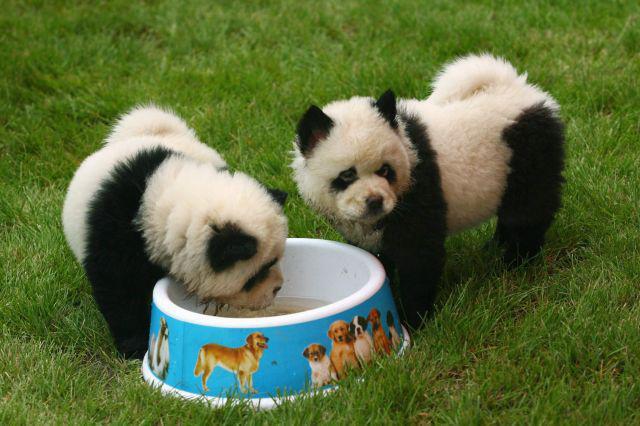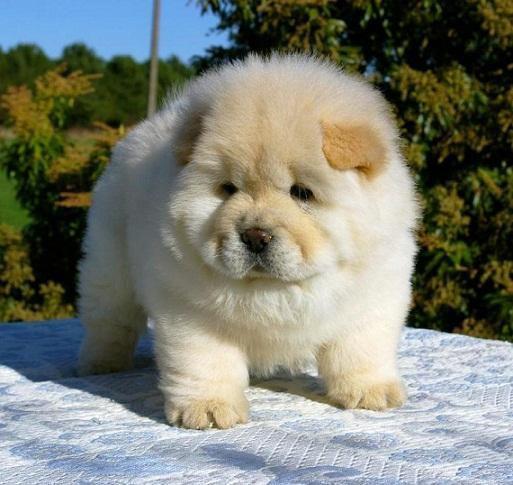The first image is the image on the left, the second image is the image on the right. Assess this claim about the two images: "Only one dog is not in the grass.". Correct or not? Answer yes or no. Yes. The first image is the image on the left, the second image is the image on the right. Examine the images to the left and right. Is the description "One dog has his left front paw off the ground." accurate? Answer yes or no. No. 